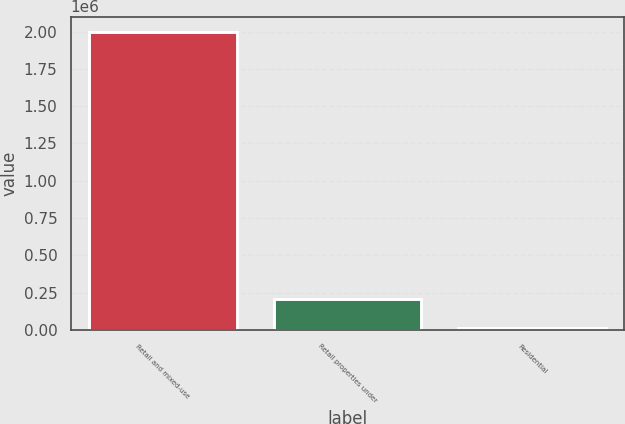Convert chart to OTSL. <chart><loc_0><loc_0><loc_500><loc_500><bar_chart><fcel>Retail and mixed-use<fcel>Retail properties under<fcel>Residential<nl><fcel>2.00027e+06<fcel>208715<fcel>9653<nl></chart> 